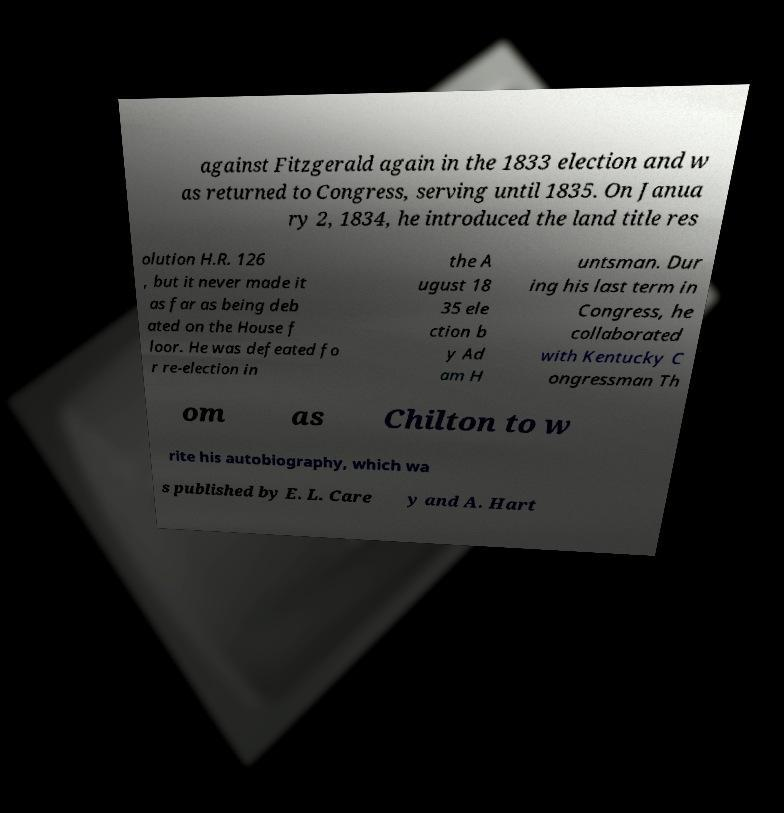Could you assist in decoding the text presented in this image and type it out clearly? against Fitzgerald again in the 1833 election and w as returned to Congress, serving until 1835. On Janua ry 2, 1834, he introduced the land title res olution H.R. 126 , but it never made it as far as being deb ated on the House f loor. He was defeated fo r re-election in the A ugust 18 35 ele ction b y Ad am H untsman. Dur ing his last term in Congress, he collaborated with Kentucky C ongressman Th om as Chilton to w rite his autobiography, which wa s published by E. L. Care y and A. Hart 